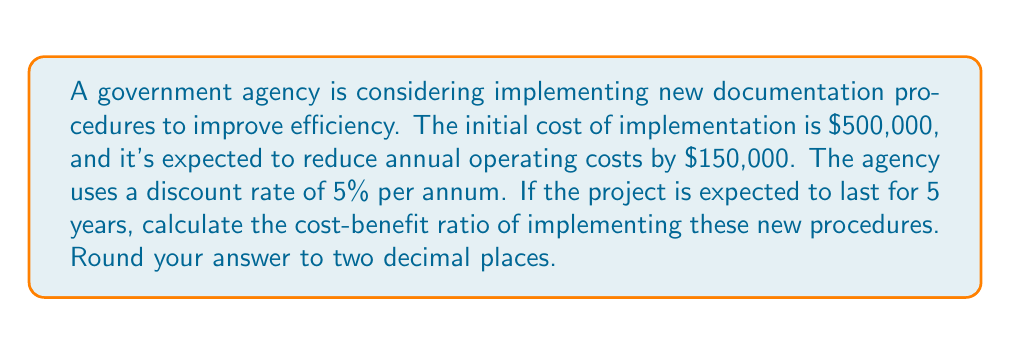Provide a solution to this math problem. To calculate the cost-benefit ratio, we need to compare the present value of benefits to the present value of costs. Let's break this down step-by-step:

1. Calculate the Present Value of Benefits:
   The benefit is the annual cost reduction of $150,000 for 5 years.
   Using the present value of an annuity formula:
   
   $$PV_{benefits} = A \cdot \frac{1 - (1+r)^{-n}}{r}$$
   
   Where:
   $A$ = Annual benefit = $150,000
   $r$ = Discount rate = 5% = 0.05
   $n$ = Number of years = 5
   
   $$PV_{benefits} = 150,000 \cdot \frac{1 - (1+0.05)^{-5}}{0.05} = 649,013.61$$

2. Calculate the Present Value of Costs:
   The cost is the initial implementation cost of $500,000.
   
   $$PV_{costs} = 500,000$$

3. Calculate the Cost-Benefit Ratio:
   
   $$Cost-Benefit\ Ratio = \frac{PV_{benefits}}{PV_{costs}} = \frac{649,013.61}{500,000} = 1.2980$$

Rounded to two decimal places, this equals 1.30.
Answer: 1.30 